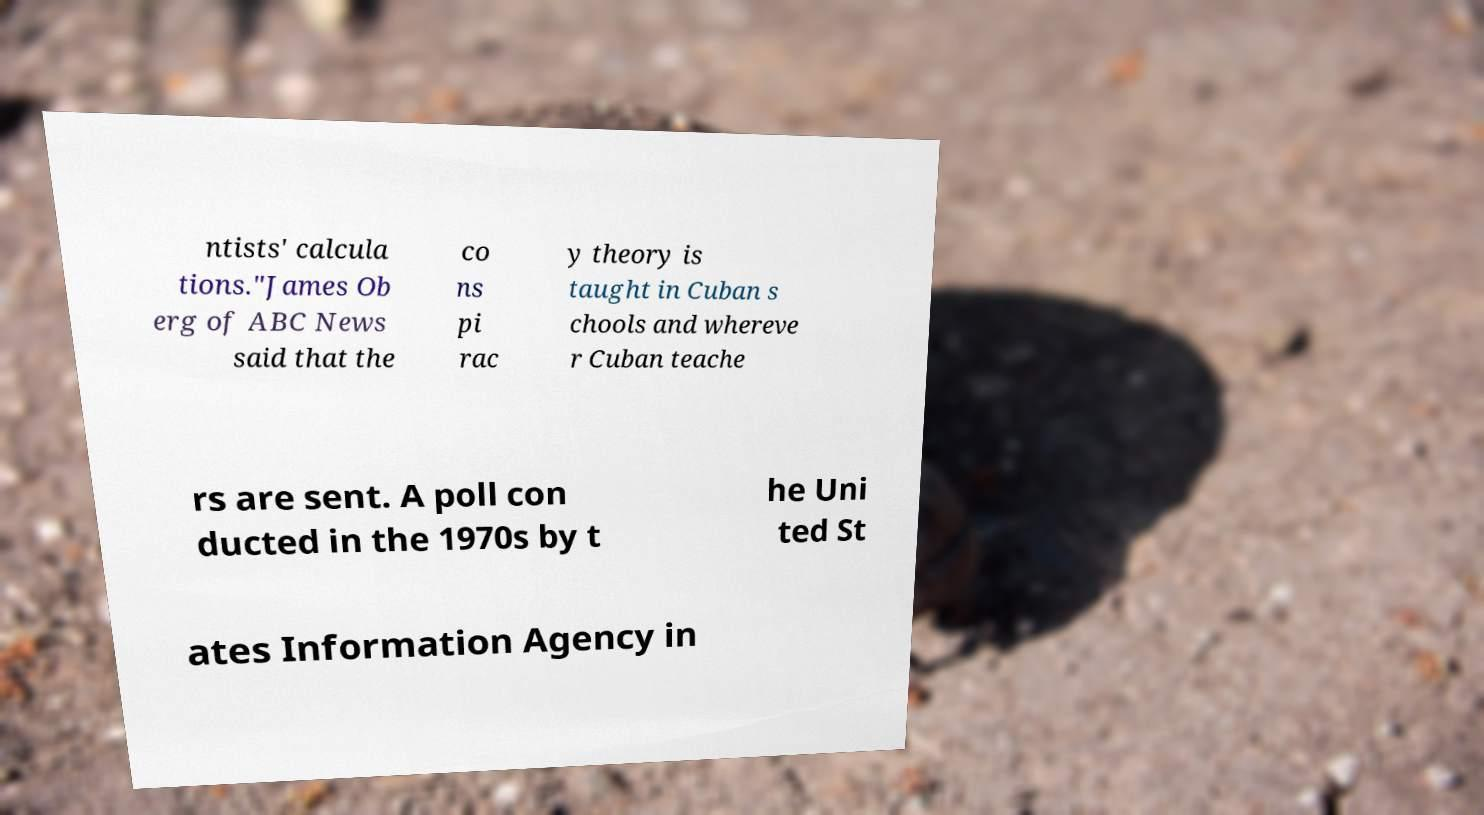Please read and relay the text visible in this image. What does it say? ntists' calcula tions."James Ob erg of ABC News said that the co ns pi rac y theory is taught in Cuban s chools and whereve r Cuban teache rs are sent. A poll con ducted in the 1970s by t he Uni ted St ates Information Agency in 